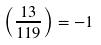Convert formula to latex. <formula><loc_0><loc_0><loc_500><loc_500>\left ( { \frac { 1 3 } { 1 1 9 } } \right ) = - 1</formula> 